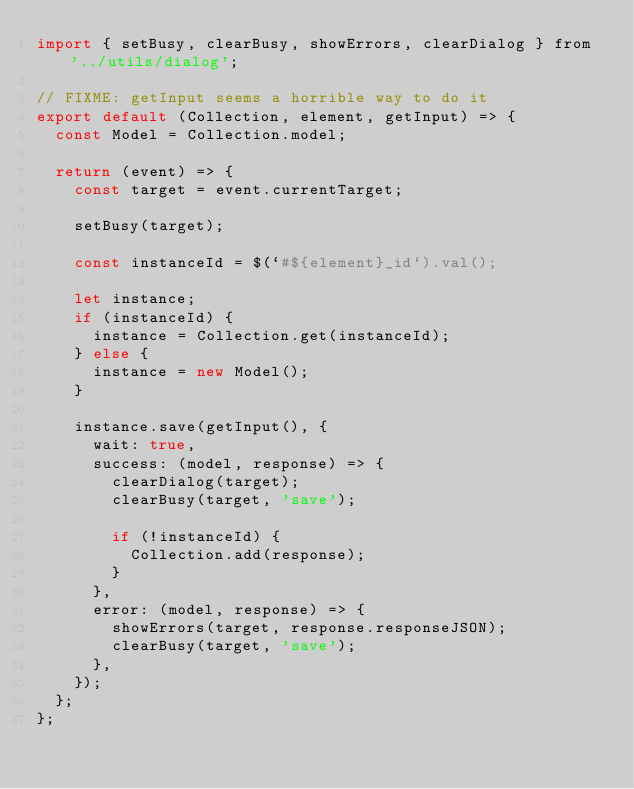Convert code to text. <code><loc_0><loc_0><loc_500><loc_500><_JavaScript_>import { setBusy, clearBusy, showErrors, clearDialog } from '../utils/dialog';

// FIXME: getInput seems a horrible way to do it
export default (Collection, element, getInput) => {
  const Model = Collection.model;

  return (event) => {
    const target = event.currentTarget;

    setBusy(target);

    const instanceId = $(`#${element}_id`).val();

    let instance;
    if (instanceId) {
      instance = Collection.get(instanceId);
    } else {
      instance = new Model();
    }

    instance.save(getInput(), {
      wait: true,
      success: (model, response) => {
        clearDialog(target);
        clearBusy(target, 'save');

        if (!instanceId) {
          Collection.add(response);
        }
      },
      error: (model, response) => {
        showErrors(target, response.responseJSON);
        clearBusy(target, 'save');
      },
    });
  };
};
</code> 